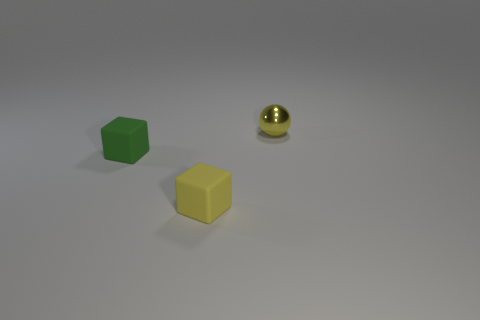Is the number of green objects greater than the number of small blocks?
Provide a short and direct response. No. There is a object that is behind the yellow matte thing and in front of the yellow ball; what size is it?
Offer a very short reply. Small. What material is the small cube that is the same color as the tiny metallic object?
Provide a short and direct response. Rubber. Are there the same number of tiny yellow metallic things on the left side of the tiny green matte object and large gray rubber cubes?
Your response must be concise. Yes. Does the ball have the same size as the yellow cube?
Keep it short and to the point. Yes. What is the color of the object that is behind the yellow rubber block and in front of the sphere?
Provide a succinct answer. Green. What material is the small yellow thing to the right of the tiny yellow thing on the left side of the small metallic sphere?
Your response must be concise. Metal. There is a yellow rubber object that is the same shape as the green matte object; what is its size?
Your response must be concise. Small. There is a tiny block that is right of the tiny green block; is its color the same as the metal object?
Give a very brief answer. Yes. Is the number of yellow objects less than the number of blue matte spheres?
Offer a terse response. No. 